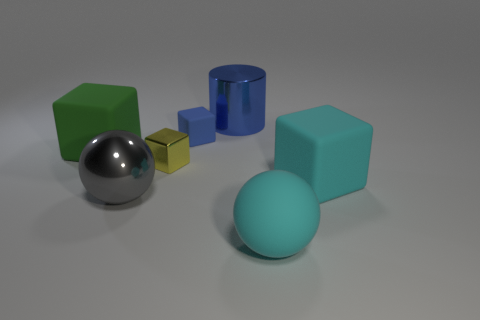How many balls are small blue matte objects or big cyan matte things?
Ensure brevity in your answer.  1. Do the rubber cube that is behind the large green matte cube and the matte sphere have the same color?
Ensure brevity in your answer.  No. There is a cylinder that is behind the matte block behind the matte cube left of the gray sphere; what is it made of?
Your response must be concise. Metal. Do the cyan cube and the blue cube have the same size?
Your answer should be compact. No. Is the color of the metal sphere the same as the big block that is in front of the yellow metal object?
Make the answer very short. No. There is a large object that is the same material as the large gray sphere; what shape is it?
Provide a succinct answer. Cylinder. Does the big cyan object on the right side of the large cyan rubber sphere have the same shape as the small blue thing?
Provide a succinct answer. Yes. There is a matte block that is in front of the big thing that is on the left side of the gray shiny ball; how big is it?
Provide a short and direct response. Large. What color is the big ball that is the same material as the blue block?
Provide a short and direct response. Cyan. What number of gray objects have the same size as the blue rubber block?
Your answer should be very brief. 0. 